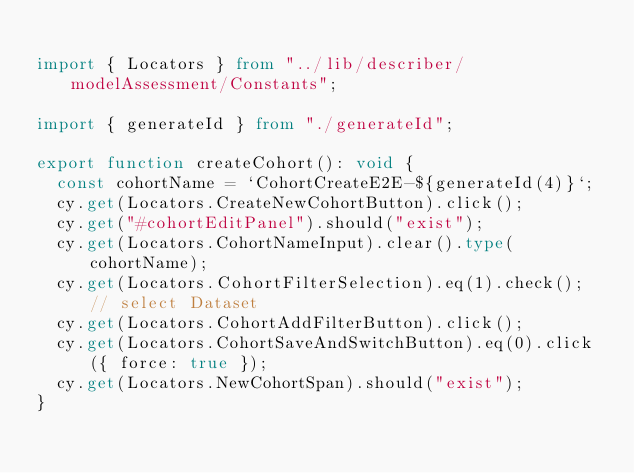Convert code to text. <code><loc_0><loc_0><loc_500><loc_500><_TypeScript_>
import { Locators } from "../lib/describer/modelAssessment/Constants";

import { generateId } from "./generateId";

export function createCohort(): void {
  const cohortName = `CohortCreateE2E-${generateId(4)}`;
  cy.get(Locators.CreateNewCohortButton).click();
  cy.get("#cohortEditPanel").should("exist");
  cy.get(Locators.CohortNameInput).clear().type(cohortName);
  cy.get(Locators.CohortFilterSelection).eq(1).check(); // select Dataset
  cy.get(Locators.CohortAddFilterButton).click();
  cy.get(Locators.CohortSaveAndSwitchButton).eq(0).click({ force: true });
  cy.get(Locators.NewCohortSpan).should("exist");
}
</code> 